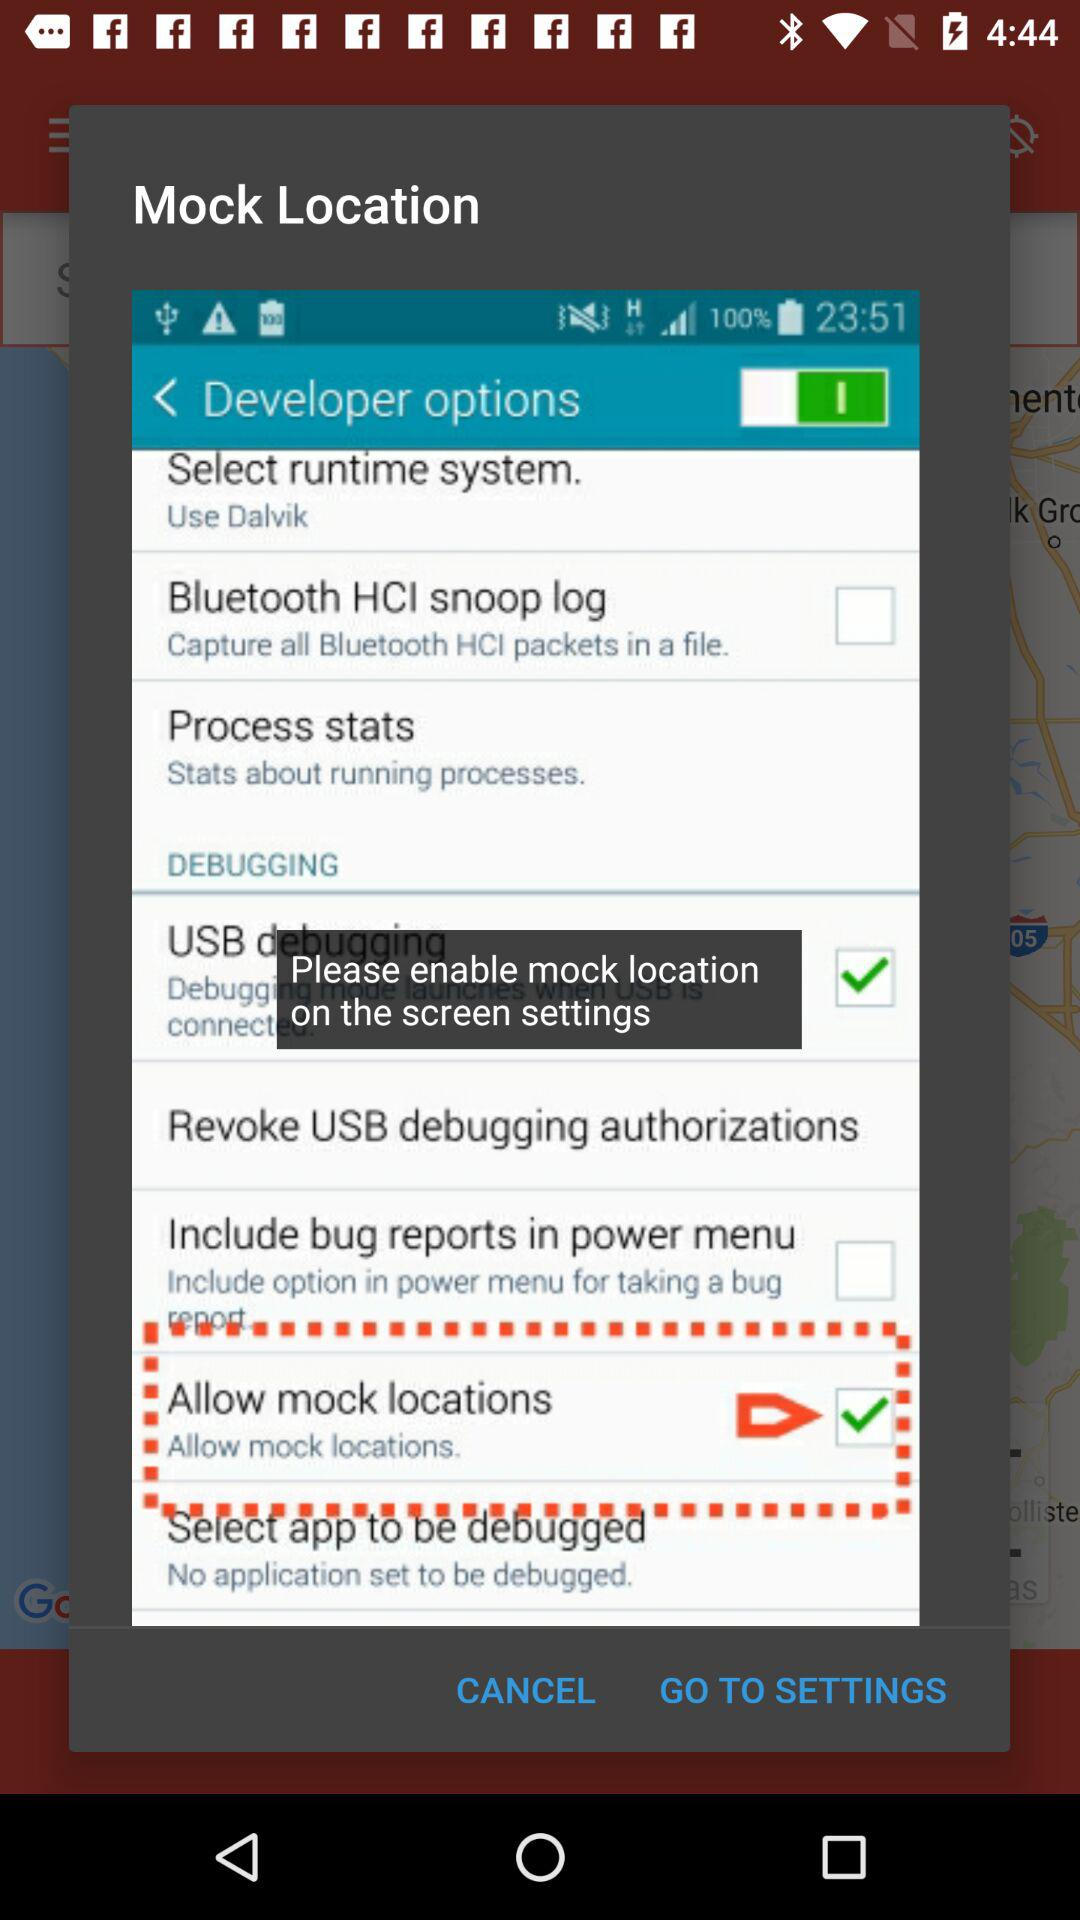What is the status of USB debugging? The status is "on". 